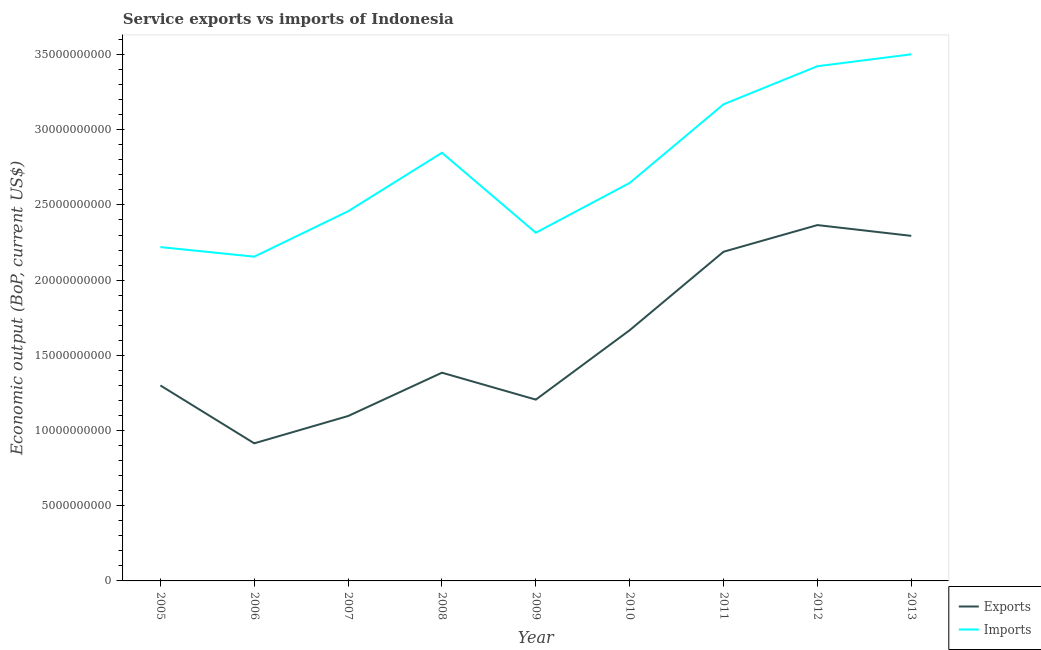How many different coloured lines are there?
Provide a short and direct response. 2. Is the number of lines equal to the number of legend labels?
Your response must be concise. Yes. What is the amount of service exports in 2011?
Your answer should be very brief. 2.19e+1. Across all years, what is the maximum amount of service exports?
Provide a succinct answer. 2.37e+1. Across all years, what is the minimum amount of service imports?
Keep it short and to the point. 2.16e+1. What is the total amount of service exports in the graph?
Make the answer very short. 1.44e+11. What is the difference between the amount of service exports in 2009 and that in 2010?
Your answer should be very brief. -4.61e+09. What is the difference between the amount of service imports in 2012 and the amount of service exports in 2006?
Provide a succinct answer. 2.51e+1. What is the average amount of service imports per year?
Offer a terse response. 2.75e+1. In the year 2009, what is the difference between the amount of service exports and amount of service imports?
Your answer should be compact. -1.11e+1. In how many years, is the amount of service imports greater than 30000000000 US$?
Make the answer very short. 3. What is the ratio of the amount of service exports in 2009 to that in 2013?
Provide a succinct answer. 0.53. Is the amount of service exports in 2008 less than that in 2010?
Ensure brevity in your answer.  Yes. Is the difference between the amount of service imports in 2011 and 2013 greater than the difference between the amount of service exports in 2011 and 2013?
Provide a succinct answer. No. What is the difference between the highest and the second highest amount of service imports?
Make the answer very short. 7.90e+08. What is the difference between the highest and the lowest amount of service exports?
Ensure brevity in your answer.  1.45e+1. In how many years, is the amount of service exports greater than the average amount of service exports taken over all years?
Your response must be concise. 4. Does the amount of service imports monotonically increase over the years?
Your answer should be compact. No. Is the amount of service imports strictly greater than the amount of service exports over the years?
Your answer should be very brief. Yes. Is the amount of service exports strictly less than the amount of service imports over the years?
Ensure brevity in your answer.  Yes. How many years are there in the graph?
Ensure brevity in your answer.  9. Does the graph contain grids?
Your answer should be very brief. No. Where does the legend appear in the graph?
Provide a short and direct response. Bottom right. What is the title of the graph?
Your answer should be compact. Service exports vs imports of Indonesia. What is the label or title of the X-axis?
Ensure brevity in your answer.  Year. What is the label or title of the Y-axis?
Provide a succinct answer. Economic output (BoP, current US$). What is the Economic output (BoP, current US$) of Exports in 2005?
Offer a very short reply. 1.30e+1. What is the Economic output (BoP, current US$) in Imports in 2005?
Give a very brief answer. 2.22e+1. What is the Economic output (BoP, current US$) in Exports in 2006?
Provide a short and direct response. 9.15e+09. What is the Economic output (BoP, current US$) of Imports in 2006?
Ensure brevity in your answer.  2.16e+1. What is the Economic output (BoP, current US$) in Exports in 2007?
Ensure brevity in your answer.  1.10e+1. What is the Economic output (BoP, current US$) in Imports in 2007?
Offer a terse response. 2.46e+1. What is the Economic output (BoP, current US$) in Exports in 2008?
Make the answer very short. 1.38e+1. What is the Economic output (BoP, current US$) in Imports in 2008?
Your response must be concise. 2.85e+1. What is the Economic output (BoP, current US$) in Exports in 2009?
Your answer should be compact. 1.21e+1. What is the Economic output (BoP, current US$) in Imports in 2009?
Give a very brief answer. 2.32e+1. What is the Economic output (BoP, current US$) of Exports in 2010?
Provide a succinct answer. 1.67e+1. What is the Economic output (BoP, current US$) of Imports in 2010?
Give a very brief answer. 2.65e+1. What is the Economic output (BoP, current US$) in Exports in 2011?
Provide a short and direct response. 2.19e+1. What is the Economic output (BoP, current US$) of Imports in 2011?
Give a very brief answer. 3.17e+1. What is the Economic output (BoP, current US$) in Exports in 2012?
Offer a terse response. 2.37e+1. What is the Economic output (BoP, current US$) of Imports in 2012?
Offer a very short reply. 3.42e+1. What is the Economic output (BoP, current US$) in Exports in 2013?
Keep it short and to the point. 2.29e+1. What is the Economic output (BoP, current US$) of Imports in 2013?
Offer a terse response. 3.50e+1. Across all years, what is the maximum Economic output (BoP, current US$) in Exports?
Offer a very short reply. 2.37e+1. Across all years, what is the maximum Economic output (BoP, current US$) in Imports?
Provide a succinct answer. 3.50e+1. Across all years, what is the minimum Economic output (BoP, current US$) of Exports?
Give a very brief answer. 9.15e+09. Across all years, what is the minimum Economic output (BoP, current US$) of Imports?
Your answer should be very brief. 2.16e+1. What is the total Economic output (BoP, current US$) in Exports in the graph?
Offer a very short reply. 1.44e+11. What is the total Economic output (BoP, current US$) of Imports in the graph?
Offer a terse response. 2.47e+11. What is the difference between the Economic output (BoP, current US$) of Exports in 2005 and that in 2006?
Make the answer very short. 3.85e+09. What is the difference between the Economic output (BoP, current US$) in Imports in 2005 and that in 2006?
Provide a short and direct response. 6.36e+08. What is the difference between the Economic output (BoP, current US$) of Exports in 2005 and that in 2007?
Your answer should be very brief. 2.03e+09. What is the difference between the Economic output (BoP, current US$) of Imports in 2005 and that in 2007?
Your answer should be compact. -2.38e+09. What is the difference between the Economic output (BoP, current US$) of Exports in 2005 and that in 2008?
Provide a short and direct response. -8.48e+08. What is the difference between the Economic output (BoP, current US$) of Imports in 2005 and that in 2008?
Give a very brief answer. -6.27e+09. What is the difference between the Economic output (BoP, current US$) in Exports in 2005 and that in 2009?
Your response must be concise. 9.42e+08. What is the difference between the Economic output (BoP, current US$) of Imports in 2005 and that in 2009?
Give a very brief answer. -9.55e+08. What is the difference between the Economic output (BoP, current US$) in Exports in 2005 and that in 2010?
Your answer should be very brief. -3.67e+09. What is the difference between the Economic output (BoP, current US$) in Imports in 2005 and that in 2010?
Offer a terse response. -4.26e+09. What is the difference between the Economic output (BoP, current US$) in Exports in 2005 and that in 2011?
Your response must be concise. -8.89e+09. What is the difference between the Economic output (BoP, current US$) in Imports in 2005 and that in 2011?
Your answer should be very brief. -9.49e+09. What is the difference between the Economic output (BoP, current US$) in Exports in 2005 and that in 2012?
Make the answer very short. -1.07e+1. What is the difference between the Economic output (BoP, current US$) of Imports in 2005 and that in 2012?
Make the answer very short. -1.20e+1. What is the difference between the Economic output (BoP, current US$) of Exports in 2005 and that in 2013?
Offer a very short reply. -9.95e+09. What is the difference between the Economic output (BoP, current US$) of Imports in 2005 and that in 2013?
Your answer should be very brief. -1.28e+1. What is the difference between the Economic output (BoP, current US$) of Exports in 2006 and that in 2007?
Give a very brief answer. -1.82e+09. What is the difference between the Economic output (BoP, current US$) of Imports in 2006 and that in 2007?
Provide a short and direct response. -3.02e+09. What is the difference between the Economic output (BoP, current US$) of Exports in 2006 and that in 2008?
Your response must be concise. -4.70e+09. What is the difference between the Economic output (BoP, current US$) in Imports in 2006 and that in 2008?
Keep it short and to the point. -6.91e+09. What is the difference between the Economic output (BoP, current US$) of Exports in 2006 and that in 2009?
Your answer should be very brief. -2.91e+09. What is the difference between the Economic output (BoP, current US$) of Imports in 2006 and that in 2009?
Provide a succinct answer. -1.59e+09. What is the difference between the Economic output (BoP, current US$) in Exports in 2006 and that in 2010?
Give a very brief answer. -7.52e+09. What is the difference between the Economic output (BoP, current US$) of Imports in 2006 and that in 2010?
Give a very brief answer. -4.90e+09. What is the difference between the Economic output (BoP, current US$) in Exports in 2006 and that in 2011?
Your answer should be very brief. -1.27e+1. What is the difference between the Economic output (BoP, current US$) of Imports in 2006 and that in 2011?
Your answer should be compact. -1.01e+1. What is the difference between the Economic output (BoP, current US$) in Exports in 2006 and that in 2012?
Provide a short and direct response. -1.45e+1. What is the difference between the Economic output (BoP, current US$) in Imports in 2006 and that in 2012?
Ensure brevity in your answer.  -1.27e+1. What is the difference between the Economic output (BoP, current US$) of Exports in 2006 and that in 2013?
Ensure brevity in your answer.  -1.38e+1. What is the difference between the Economic output (BoP, current US$) in Imports in 2006 and that in 2013?
Provide a short and direct response. -1.35e+1. What is the difference between the Economic output (BoP, current US$) of Exports in 2007 and that in 2008?
Give a very brief answer. -2.88e+09. What is the difference between the Economic output (BoP, current US$) in Imports in 2007 and that in 2008?
Provide a short and direct response. -3.89e+09. What is the difference between the Economic output (BoP, current US$) in Exports in 2007 and that in 2009?
Offer a terse response. -1.09e+09. What is the difference between the Economic output (BoP, current US$) of Imports in 2007 and that in 2009?
Your response must be concise. 1.43e+09. What is the difference between the Economic output (BoP, current US$) in Exports in 2007 and that in 2010?
Keep it short and to the point. -5.71e+09. What is the difference between the Economic output (BoP, current US$) of Imports in 2007 and that in 2010?
Your answer should be very brief. -1.88e+09. What is the difference between the Economic output (BoP, current US$) of Exports in 2007 and that in 2011?
Give a very brief answer. -1.09e+1. What is the difference between the Economic output (BoP, current US$) of Imports in 2007 and that in 2011?
Offer a very short reply. -7.11e+09. What is the difference between the Economic output (BoP, current US$) in Exports in 2007 and that in 2012?
Your answer should be very brief. -1.27e+1. What is the difference between the Economic output (BoP, current US$) in Imports in 2007 and that in 2012?
Keep it short and to the point. -9.65e+09. What is the difference between the Economic output (BoP, current US$) in Exports in 2007 and that in 2013?
Provide a short and direct response. -1.20e+1. What is the difference between the Economic output (BoP, current US$) in Imports in 2007 and that in 2013?
Provide a short and direct response. -1.04e+1. What is the difference between the Economic output (BoP, current US$) of Exports in 2008 and that in 2009?
Make the answer very short. 1.79e+09. What is the difference between the Economic output (BoP, current US$) of Imports in 2008 and that in 2009?
Give a very brief answer. 5.32e+09. What is the difference between the Economic output (BoP, current US$) of Exports in 2008 and that in 2010?
Offer a very short reply. -2.83e+09. What is the difference between the Economic output (BoP, current US$) of Imports in 2008 and that in 2010?
Your response must be concise. 2.01e+09. What is the difference between the Economic output (BoP, current US$) of Exports in 2008 and that in 2011?
Offer a terse response. -8.04e+09. What is the difference between the Economic output (BoP, current US$) of Imports in 2008 and that in 2011?
Offer a very short reply. -3.22e+09. What is the difference between the Economic output (BoP, current US$) in Exports in 2008 and that in 2012?
Provide a succinct answer. -9.81e+09. What is the difference between the Economic output (BoP, current US$) in Imports in 2008 and that in 2012?
Keep it short and to the point. -5.75e+09. What is the difference between the Economic output (BoP, current US$) in Exports in 2008 and that in 2013?
Ensure brevity in your answer.  -9.10e+09. What is the difference between the Economic output (BoP, current US$) of Imports in 2008 and that in 2013?
Offer a very short reply. -6.54e+09. What is the difference between the Economic output (BoP, current US$) in Exports in 2009 and that in 2010?
Your response must be concise. -4.61e+09. What is the difference between the Economic output (BoP, current US$) of Imports in 2009 and that in 2010?
Make the answer very short. -3.31e+09. What is the difference between the Economic output (BoP, current US$) of Exports in 2009 and that in 2011?
Your answer should be very brief. -9.83e+09. What is the difference between the Economic output (BoP, current US$) in Imports in 2009 and that in 2011?
Give a very brief answer. -8.54e+09. What is the difference between the Economic output (BoP, current US$) of Exports in 2009 and that in 2012?
Your answer should be compact. -1.16e+1. What is the difference between the Economic output (BoP, current US$) in Imports in 2009 and that in 2012?
Your response must be concise. -1.11e+1. What is the difference between the Economic output (BoP, current US$) of Exports in 2009 and that in 2013?
Provide a short and direct response. -1.09e+1. What is the difference between the Economic output (BoP, current US$) of Imports in 2009 and that in 2013?
Offer a very short reply. -1.19e+1. What is the difference between the Economic output (BoP, current US$) in Exports in 2010 and that in 2011?
Your response must be concise. -5.22e+09. What is the difference between the Economic output (BoP, current US$) in Imports in 2010 and that in 2011?
Your response must be concise. -5.23e+09. What is the difference between the Economic output (BoP, current US$) in Exports in 2010 and that in 2012?
Keep it short and to the point. -6.99e+09. What is the difference between the Economic output (BoP, current US$) in Imports in 2010 and that in 2012?
Make the answer very short. -7.76e+09. What is the difference between the Economic output (BoP, current US$) of Exports in 2010 and that in 2013?
Offer a terse response. -6.27e+09. What is the difference between the Economic output (BoP, current US$) in Imports in 2010 and that in 2013?
Make the answer very short. -8.55e+09. What is the difference between the Economic output (BoP, current US$) in Exports in 2011 and that in 2012?
Ensure brevity in your answer.  -1.77e+09. What is the difference between the Economic output (BoP, current US$) in Imports in 2011 and that in 2012?
Offer a terse response. -2.53e+09. What is the difference between the Economic output (BoP, current US$) in Exports in 2011 and that in 2013?
Ensure brevity in your answer.  -1.06e+09. What is the difference between the Economic output (BoP, current US$) of Imports in 2011 and that in 2013?
Offer a terse response. -3.32e+09. What is the difference between the Economic output (BoP, current US$) of Exports in 2012 and that in 2013?
Your answer should be compact. 7.16e+08. What is the difference between the Economic output (BoP, current US$) of Imports in 2012 and that in 2013?
Make the answer very short. -7.90e+08. What is the difference between the Economic output (BoP, current US$) of Exports in 2005 and the Economic output (BoP, current US$) of Imports in 2006?
Your response must be concise. -8.56e+09. What is the difference between the Economic output (BoP, current US$) of Exports in 2005 and the Economic output (BoP, current US$) of Imports in 2007?
Your answer should be compact. -1.16e+1. What is the difference between the Economic output (BoP, current US$) in Exports in 2005 and the Economic output (BoP, current US$) in Imports in 2008?
Your response must be concise. -1.55e+1. What is the difference between the Economic output (BoP, current US$) in Exports in 2005 and the Economic output (BoP, current US$) in Imports in 2009?
Keep it short and to the point. -1.02e+1. What is the difference between the Economic output (BoP, current US$) in Exports in 2005 and the Economic output (BoP, current US$) in Imports in 2010?
Keep it short and to the point. -1.35e+1. What is the difference between the Economic output (BoP, current US$) of Exports in 2005 and the Economic output (BoP, current US$) of Imports in 2011?
Your answer should be compact. -1.87e+1. What is the difference between the Economic output (BoP, current US$) in Exports in 2005 and the Economic output (BoP, current US$) in Imports in 2012?
Offer a terse response. -2.12e+1. What is the difference between the Economic output (BoP, current US$) in Exports in 2005 and the Economic output (BoP, current US$) in Imports in 2013?
Provide a short and direct response. -2.20e+1. What is the difference between the Economic output (BoP, current US$) in Exports in 2006 and the Economic output (BoP, current US$) in Imports in 2007?
Make the answer very short. -1.54e+1. What is the difference between the Economic output (BoP, current US$) of Exports in 2006 and the Economic output (BoP, current US$) of Imports in 2008?
Your answer should be very brief. -1.93e+1. What is the difference between the Economic output (BoP, current US$) in Exports in 2006 and the Economic output (BoP, current US$) in Imports in 2009?
Your answer should be compact. -1.40e+1. What is the difference between the Economic output (BoP, current US$) of Exports in 2006 and the Economic output (BoP, current US$) of Imports in 2010?
Provide a succinct answer. -1.73e+1. What is the difference between the Economic output (BoP, current US$) in Exports in 2006 and the Economic output (BoP, current US$) in Imports in 2011?
Keep it short and to the point. -2.25e+1. What is the difference between the Economic output (BoP, current US$) of Exports in 2006 and the Economic output (BoP, current US$) of Imports in 2012?
Make the answer very short. -2.51e+1. What is the difference between the Economic output (BoP, current US$) of Exports in 2006 and the Economic output (BoP, current US$) of Imports in 2013?
Offer a terse response. -2.59e+1. What is the difference between the Economic output (BoP, current US$) of Exports in 2007 and the Economic output (BoP, current US$) of Imports in 2008?
Give a very brief answer. -1.75e+1. What is the difference between the Economic output (BoP, current US$) of Exports in 2007 and the Economic output (BoP, current US$) of Imports in 2009?
Your answer should be very brief. -1.22e+1. What is the difference between the Economic output (BoP, current US$) in Exports in 2007 and the Economic output (BoP, current US$) in Imports in 2010?
Keep it short and to the point. -1.55e+1. What is the difference between the Economic output (BoP, current US$) of Exports in 2007 and the Economic output (BoP, current US$) of Imports in 2011?
Keep it short and to the point. -2.07e+1. What is the difference between the Economic output (BoP, current US$) in Exports in 2007 and the Economic output (BoP, current US$) in Imports in 2012?
Your response must be concise. -2.33e+1. What is the difference between the Economic output (BoP, current US$) of Exports in 2007 and the Economic output (BoP, current US$) of Imports in 2013?
Offer a terse response. -2.41e+1. What is the difference between the Economic output (BoP, current US$) of Exports in 2008 and the Economic output (BoP, current US$) of Imports in 2009?
Offer a very short reply. -9.31e+09. What is the difference between the Economic output (BoP, current US$) in Exports in 2008 and the Economic output (BoP, current US$) in Imports in 2010?
Ensure brevity in your answer.  -1.26e+1. What is the difference between the Economic output (BoP, current US$) in Exports in 2008 and the Economic output (BoP, current US$) in Imports in 2011?
Make the answer very short. -1.78e+1. What is the difference between the Economic output (BoP, current US$) in Exports in 2008 and the Economic output (BoP, current US$) in Imports in 2012?
Give a very brief answer. -2.04e+1. What is the difference between the Economic output (BoP, current US$) of Exports in 2008 and the Economic output (BoP, current US$) of Imports in 2013?
Your answer should be very brief. -2.12e+1. What is the difference between the Economic output (BoP, current US$) in Exports in 2009 and the Economic output (BoP, current US$) in Imports in 2010?
Your answer should be very brief. -1.44e+1. What is the difference between the Economic output (BoP, current US$) of Exports in 2009 and the Economic output (BoP, current US$) of Imports in 2011?
Your answer should be compact. -1.96e+1. What is the difference between the Economic output (BoP, current US$) in Exports in 2009 and the Economic output (BoP, current US$) in Imports in 2012?
Keep it short and to the point. -2.22e+1. What is the difference between the Economic output (BoP, current US$) in Exports in 2009 and the Economic output (BoP, current US$) in Imports in 2013?
Offer a terse response. -2.30e+1. What is the difference between the Economic output (BoP, current US$) in Exports in 2010 and the Economic output (BoP, current US$) in Imports in 2011?
Offer a terse response. -1.50e+1. What is the difference between the Economic output (BoP, current US$) in Exports in 2010 and the Economic output (BoP, current US$) in Imports in 2012?
Your answer should be compact. -1.76e+1. What is the difference between the Economic output (BoP, current US$) of Exports in 2010 and the Economic output (BoP, current US$) of Imports in 2013?
Make the answer very short. -1.83e+1. What is the difference between the Economic output (BoP, current US$) of Exports in 2011 and the Economic output (BoP, current US$) of Imports in 2012?
Provide a short and direct response. -1.23e+1. What is the difference between the Economic output (BoP, current US$) in Exports in 2011 and the Economic output (BoP, current US$) in Imports in 2013?
Keep it short and to the point. -1.31e+1. What is the difference between the Economic output (BoP, current US$) of Exports in 2012 and the Economic output (BoP, current US$) of Imports in 2013?
Offer a terse response. -1.14e+1. What is the average Economic output (BoP, current US$) of Exports per year?
Give a very brief answer. 1.60e+1. What is the average Economic output (BoP, current US$) in Imports per year?
Offer a very short reply. 2.75e+1. In the year 2005, what is the difference between the Economic output (BoP, current US$) in Exports and Economic output (BoP, current US$) in Imports?
Keep it short and to the point. -9.20e+09. In the year 2006, what is the difference between the Economic output (BoP, current US$) of Exports and Economic output (BoP, current US$) of Imports?
Ensure brevity in your answer.  -1.24e+1. In the year 2007, what is the difference between the Economic output (BoP, current US$) in Exports and Economic output (BoP, current US$) in Imports?
Offer a terse response. -1.36e+1. In the year 2008, what is the difference between the Economic output (BoP, current US$) in Exports and Economic output (BoP, current US$) in Imports?
Give a very brief answer. -1.46e+1. In the year 2009, what is the difference between the Economic output (BoP, current US$) in Exports and Economic output (BoP, current US$) in Imports?
Provide a succinct answer. -1.11e+1. In the year 2010, what is the difference between the Economic output (BoP, current US$) in Exports and Economic output (BoP, current US$) in Imports?
Make the answer very short. -9.79e+09. In the year 2011, what is the difference between the Economic output (BoP, current US$) in Exports and Economic output (BoP, current US$) in Imports?
Keep it short and to the point. -9.80e+09. In the year 2012, what is the difference between the Economic output (BoP, current US$) in Exports and Economic output (BoP, current US$) in Imports?
Provide a short and direct response. -1.06e+1. In the year 2013, what is the difference between the Economic output (BoP, current US$) of Exports and Economic output (BoP, current US$) of Imports?
Give a very brief answer. -1.21e+1. What is the ratio of the Economic output (BoP, current US$) in Exports in 2005 to that in 2006?
Your response must be concise. 1.42. What is the ratio of the Economic output (BoP, current US$) of Imports in 2005 to that in 2006?
Offer a terse response. 1.03. What is the ratio of the Economic output (BoP, current US$) in Exports in 2005 to that in 2007?
Your answer should be compact. 1.19. What is the ratio of the Economic output (BoP, current US$) in Imports in 2005 to that in 2007?
Offer a very short reply. 0.9. What is the ratio of the Economic output (BoP, current US$) in Exports in 2005 to that in 2008?
Your response must be concise. 0.94. What is the ratio of the Economic output (BoP, current US$) of Imports in 2005 to that in 2008?
Your answer should be compact. 0.78. What is the ratio of the Economic output (BoP, current US$) of Exports in 2005 to that in 2009?
Your response must be concise. 1.08. What is the ratio of the Economic output (BoP, current US$) of Imports in 2005 to that in 2009?
Give a very brief answer. 0.96. What is the ratio of the Economic output (BoP, current US$) in Exports in 2005 to that in 2010?
Make the answer very short. 0.78. What is the ratio of the Economic output (BoP, current US$) of Imports in 2005 to that in 2010?
Offer a very short reply. 0.84. What is the ratio of the Economic output (BoP, current US$) in Exports in 2005 to that in 2011?
Your response must be concise. 0.59. What is the ratio of the Economic output (BoP, current US$) in Imports in 2005 to that in 2011?
Keep it short and to the point. 0.7. What is the ratio of the Economic output (BoP, current US$) in Exports in 2005 to that in 2012?
Give a very brief answer. 0.55. What is the ratio of the Economic output (BoP, current US$) in Imports in 2005 to that in 2012?
Your answer should be compact. 0.65. What is the ratio of the Economic output (BoP, current US$) of Exports in 2005 to that in 2013?
Offer a terse response. 0.57. What is the ratio of the Economic output (BoP, current US$) in Imports in 2005 to that in 2013?
Your response must be concise. 0.63. What is the ratio of the Economic output (BoP, current US$) in Exports in 2006 to that in 2007?
Your answer should be very brief. 0.83. What is the ratio of the Economic output (BoP, current US$) of Imports in 2006 to that in 2007?
Offer a very short reply. 0.88. What is the ratio of the Economic output (BoP, current US$) of Exports in 2006 to that in 2008?
Your response must be concise. 0.66. What is the ratio of the Economic output (BoP, current US$) of Imports in 2006 to that in 2008?
Ensure brevity in your answer.  0.76. What is the ratio of the Economic output (BoP, current US$) of Exports in 2006 to that in 2009?
Offer a very short reply. 0.76. What is the ratio of the Economic output (BoP, current US$) of Imports in 2006 to that in 2009?
Ensure brevity in your answer.  0.93. What is the ratio of the Economic output (BoP, current US$) in Exports in 2006 to that in 2010?
Ensure brevity in your answer.  0.55. What is the ratio of the Economic output (BoP, current US$) in Imports in 2006 to that in 2010?
Your answer should be compact. 0.81. What is the ratio of the Economic output (BoP, current US$) of Exports in 2006 to that in 2011?
Offer a terse response. 0.42. What is the ratio of the Economic output (BoP, current US$) of Imports in 2006 to that in 2011?
Provide a short and direct response. 0.68. What is the ratio of the Economic output (BoP, current US$) of Exports in 2006 to that in 2012?
Provide a short and direct response. 0.39. What is the ratio of the Economic output (BoP, current US$) in Imports in 2006 to that in 2012?
Provide a short and direct response. 0.63. What is the ratio of the Economic output (BoP, current US$) in Exports in 2006 to that in 2013?
Offer a very short reply. 0.4. What is the ratio of the Economic output (BoP, current US$) in Imports in 2006 to that in 2013?
Your answer should be very brief. 0.62. What is the ratio of the Economic output (BoP, current US$) in Exports in 2007 to that in 2008?
Give a very brief answer. 0.79. What is the ratio of the Economic output (BoP, current US$) of Imports in 2007 to that in 2008?
Make the answer very short. 0.86. What is the ratio of the Economic output (BoP, current US$) in Exports in 2007 to that in 2009?
Offer a terse response. 0.91. What is the ratio of the Economic output (BoP, current US$) in Imports in 2007 to that in 2009?
Ensure brevity in your answer.  1.06. What is the ratio of the Economic output (BoP, current US$) of Exports in 2007 to that in 2010?
Your answer should be compact. 0.66. What is the ratio of the Economic output (BoP, current US$) in Imports in 2007 to that in 2010?
Keep it short and to the point. 0.93. What is the ratio of the Economic output (BoP, current US$) of Exports in 2007 to that in 2011?
Ensure brevity in your answer.  0.5. What is the ratio of the Economic output (BoP, current US$) in Imports in 2007 to that in 2011?
Make the answer very short. 0.78. What is the ratio of the Economic output (BoP, current US$) of Exports in 2007 to that in 2012?
Your answer should be compact. 0.46. What is the ratio of the Economic output (BoP, current US$) of Imports in 2007 to that in 2012?
Make the answer very short. 0.72. What is the ratio of the Economic output (BoP, current US$) in Exports in 2007 to that in 2013?
Offer a terse response. 0.48. What is the ratio of the Economic output (BoP, current US$) in Imports in 2007 to that in 2013?
Your answer should be compact. 0.7. What is the ratio of the Economic output (BoP, current US$) of Exports in 2008 to that in 2009?
Your answer should be very brief. 1.15. What is the ratio of the Economic output (BoP, current US$) of Imports in 2008 to that in 2009?
Offer a terse response. 1.23. What is the ratio of the Economic output (BoP, current US$) of Exports in 2008 to that in 2010?
Make the answer very short. 0.83. What is the ratio of the Economic output (BoP, current US$) of Imports in 2008 to that in 2010?
Your answer should be compact. 1.08. What is the ratio of the Economic output (BoP, current US$) in Exports in 2008 to that in 2011?
Offer a very short reply. 0.63. What is the ratio of the Economic output (BoP, current US$) in Imports in 2008 to that in 2011?
Offer a terse response. 0.9. What is the ratio of the Economic output (BoP, current US$) of Exports in 2008 to that in 2012?
Offer a terse response. 0.59. What is the ratio of the Economic output (BoP, current US$) of Imports in 2008 to that in 2012?
Provide a short and direct response. 0.83. What is the ratio of the Economic output (BoP, current US$) in Exports in 2008 to that in 2013?
Your answer should be compact. 0.6. What is the ratio of the Economic output (BoP, current US$) of Imports in 2008 to that in 2013?
Offer a very short reply. 0.81. What is the ratio of the Economic output (BoP, current US$) in Exports in 2009 to that in 2010?
Make the answer very short. 0.72. What is the ratio of the Economic output (BoP, current US$) of Imports in 2009 to that in 2010?
Keep it short and to the point. 0.87. What is the ratio of the Economic output (BoP, current US$) in Exports in 2009 to that in 2011?
Provide a succinct answer. 0.55. What is the ratio of the Economic output (BoP, current US$) of Imports in 2009 to that in 2011?
Keep it short and to the point. 0.73. What is the ratio of the Economic output (BoP, current US$) of Exports in 2009 to that in 2012?
Provide a short and direct response. 0.51. What is the ratio of the Economic output (BoP, current US$) in Imports in 2009 to that in 2012?
Give a very brief answer. 0.68. What is the ratio of the Economic output (BoP, current US$) of Exports in 2009 to that in 2013?
Provide a short and direct response. 0.53. What is the ratio of the Economic output (BoP, current US$) in Imports in 2009 to that in 2013?
Your answer should be compact. 0.66. What is the ratio of the Economic output (BoP, current US$) of Exports in 2010 to that in 2011?
Keep it short and to the point. 0.76. What is the ratio of the Economic output (BoP, current US$) of Imports in 2010 to that in 2011?
Provide a short and direct response. 0.83. What is the ratio of the Economic output (BoP, current US$) in Exports in 2010 to that in 2012?
Give a very brief answer. 0.7. What is the ratio of the Economic output (BoP, current US$) in Imports in 2010 to that in 2012?
Your response must be concise. 0.77. What is the ratio of the Economic output (BoP, current US$) of Exports in 2010 to that in 2013?
Ensure brevity in your answer.  0.73. What is the ratio of the Economic output (BoP, current US$) in Imports in 2010 to that in 2013?
Ensure brevity in your answer.  0.76. What is the ratio of the Economic output (BoP, current US$) of Exports in 2011 to that in 2012?
Make the answer very short. 0.93. What is the ratio of the Economic output (BoP, current US$) in Imports in 2011 to that in 2012?
Keep it short and to the point. 0.93. What is the ratio of the Economic output (BoP, current US$) in Exports in 2011 to that in 2013?
Your answer should be compact. 0.95. What is the ratio of the Economic output (BoP, current US$) in Imports in 2011 to that in 2013?
Ensure brevity in your answer.  0.91. What is the ratio of the Economic output (BoP, current US$) of Exports in 2012 to that in 2013?
Make the answer very short. 1.03. What is the ratio of the Economic output (BoP, current US$) in Imports in 2012 to that in 2013?
Your response must be concise. 0.98. What is the difference between the highest and the second highest Economic output (BoP, current US$) of Exports?
Give a very brief answer. 7.16e+08. What is the difference between the highest and the second highest Economic output (BoP, current US$) of Imports?
Ensure brevity in your answer.  7.90e+08. What is the difference between the highest and the lowest Economic output (BoP, current US$) of Exports?
Offer a very short reply. 1.45e+1. What is the difference between the highest and the lowest Economic output (BoP, current US$) of Imports?
Offer a terse response. 1.35e+1. 